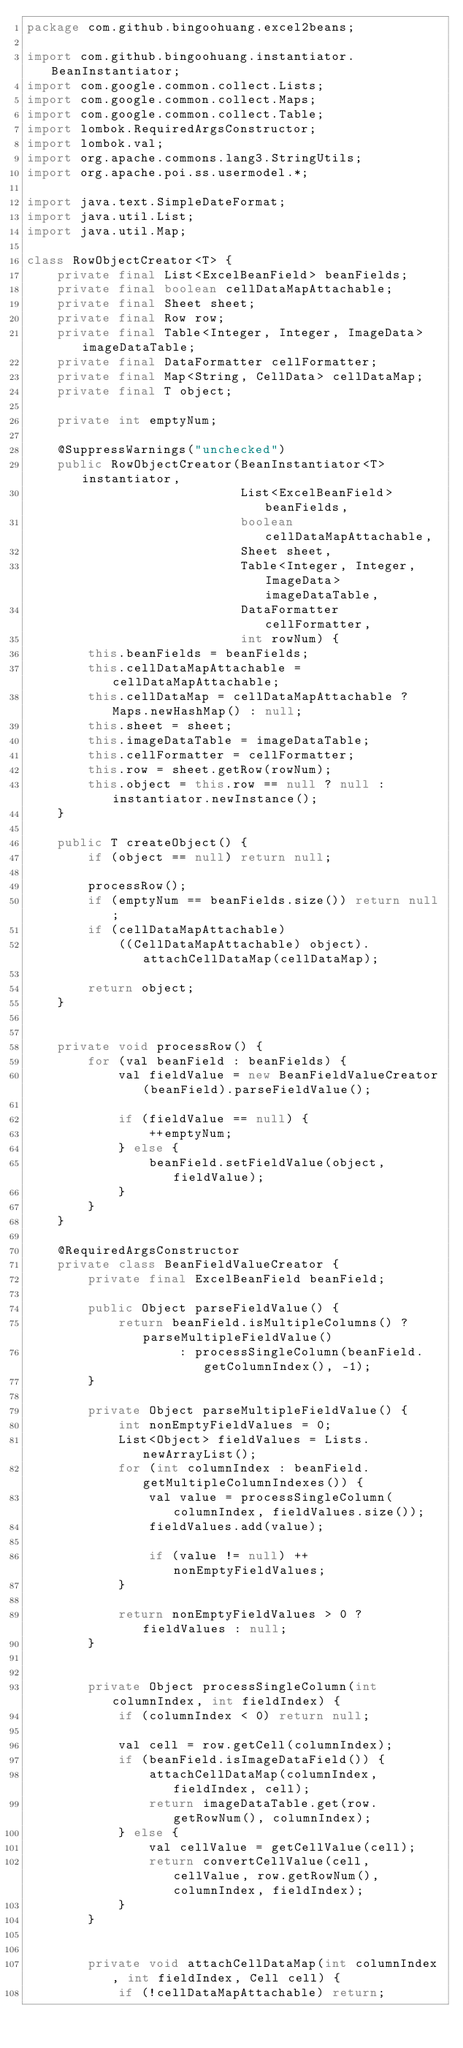Convert code to text. <code><loc_0><loc_0><loc_500><loc_500><_Java_>package com.github.bingoohuang.excel2beans;

import com.github.bingoohuang.instantiator.BeanInstantiator;
import com.google.common.collect.Lists;
import com.google.common.collect.Maps;
import com.google.common.collect.Table;
import lombok.RequiredArgsConstructor;
import lombok.val;
import org.apache.commons.lang3.StringUtils;
import org.apache.poi.ss.usermodel.*;

import java.text.SimpleDateFormat;
import java.util.List;
import java.util.Map;

class RowObjectCreator<T> {
    private final List<ExcelBeanField> beanFields;
    private final boolean cellDataMapAttachable;
    private final Sheet sheet;
    private final Row row;
    private final Table<Integer, Integer, ImageData> imageDataTable;
    private final DataFormatter cellFormatter;
    private final Map<String, CellData> cellDataMap;
    private final T object;

    private int emptyNum;

    @SuppressWarnings("unchecked")
    public RowObjectCreator(BeanInstantiator<T> instantiator,
                            List<ExcelBeanField> beanFields,
                            boolean cellDataMapAttachable,
                            Sheet sheet,
                            Table<Integer, Integer, ImageData> imageDataTable,
                            DataFormatter cellFormatter,
                            int rowNum) {
        this.beanFields = beanFields;
        this.cellDataMapAttachable = cellDataMapAttachable;
        this.cellDataMap = cellDataMapAttachable ? Maps.newHashMap() : null;
        this.sheet = sheet;
        this.imageDataTable = imageDataTable;
        this.cellFormatter = cellFormatter;
        this.row = sheet.getRow(rowNum);
        this.object = this.row == null ? null : instantiator.newInstance();
    }

    public T createObject() {
        if (object == null) return null;

        processRow();
        if (emptyNum == beanFields.size()) return null;
        if (cellDataMapAttachable)
            ((CellDataMapAttachable) object).attachCellDataMap(cellDataMap);

        return object;
    }


    private void processRow() {
        for (val beanField : beanFields) {
            val fieldValue = new BeanFieldValueCreator(beanField).parseFieldValue();

            if (fieldValue == null) {
                ++emptyNum;
            } else {
                beanField.setFieldValue(object, fieldValue);
            }
        }
    }

    @RequiredArgsConstructor
    private class BeanFieldValueCreator {
        private final ExcelBeanField beanField;

        public Object parseFieldValue() {
            return beanField.isMultipleColumns() ? parseMultipleFieldValue()
                    : processSingleColumn(beanField.getColumnIndex(), -1);
        }

        private Object parseMultipleFieldValue() {
            int nonEmptyFieldValues = 0;
            List<Object> fieldValues = Lists.newArrayList();
            for (int columnIndex : beanField.getMultipleColumnIndexes()) {
                val value = processSingleColumn(columnIndex, fieldValues.size());
                fieldValues.add(value);

                if (value != null) ++nonEmptyFieldValues;
            }

            return nonEmptyFieldValues > 0 ? fieldValues : null;
        }


        private Object processSingleColumn(int columnIndex, int fieldIndex) {
            if (columnIndex < 0) return null;

            val cell = row.getCell(columnIndex);
            if (beanField.isImageDataField()) {
                attachCellDataMap(columnIndex, fieldIndex, cell);
                return imageDataTable.get(row.getRowNum(), columnIndex);
            } else {
                val cellValue = getCellValue(cell);
                return convertCellValue(cell, cellValue, row.getRowNum(), columnIndex, fieldIndex);
            }
        }


        private void attachCellDataMap(int columnIndex, int fieldIndex, Cell cell) {
            if (!cellDataMapAttachable) return;
</code> 